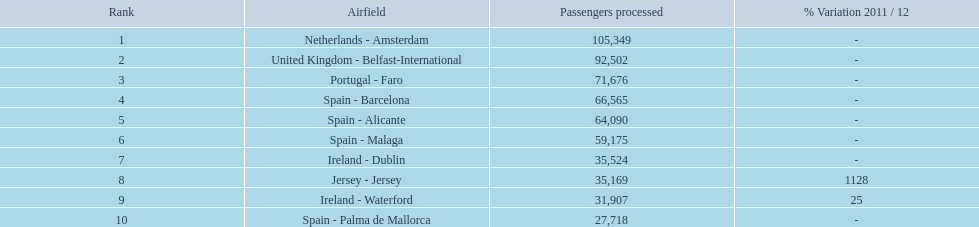What's the count of passengers en route to or coming back from spain? 217,548. Can you give me this table as a dict? {'header': ['Rank', 'Airfield', 'Passengers processed', '% Variation 2011 / 12'], 'rows': [['1', 'Netherlands - Amsterdam', '105,349', '-'], ['2', 'United Kingdom - Belfast-International', '92,502', '-'], ['3', 'Portugal - Faro', '71,676', '-'], ['4', 'Spain - Barcelona', '66,565', '-'], ['5', 'Spain - Alicante', '64,090', '-'], ['6', 'Spain - Malaga', '59,175', '-'], ['7', 'Ireland - Dublin', '35,524', '-'], ['8', 'Jersey - Jersey', '35,169', '1128'], ['9', 'Ireland - Waterford', '31,907', '25'], ['10', 'Spain - Palma de Mallorca', '27,718', '-']]} 